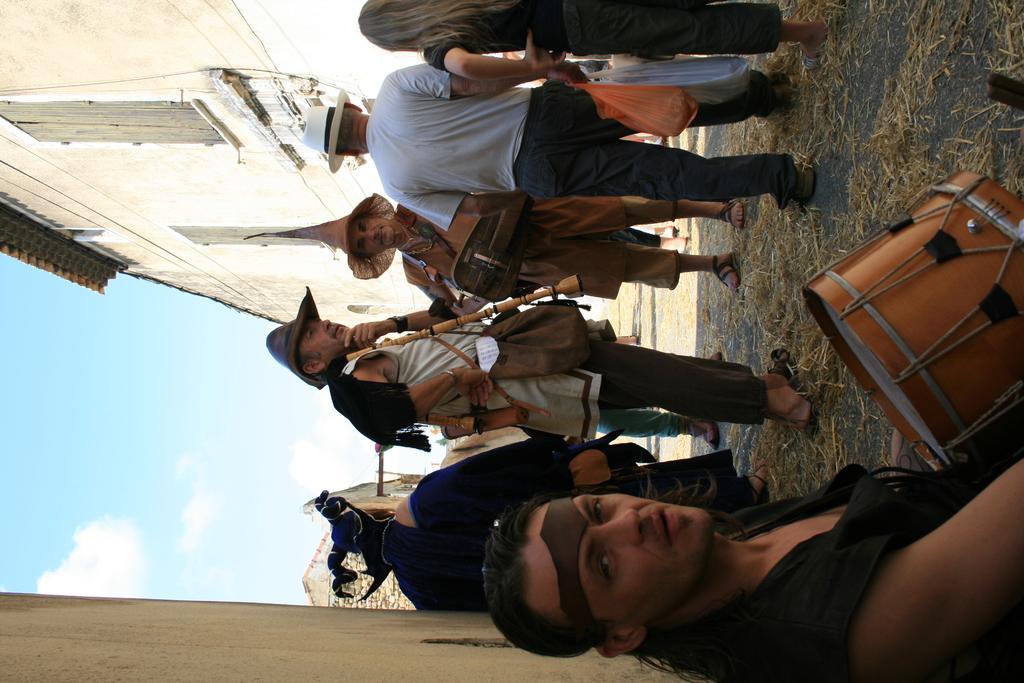How would you summarize this image in a sentence or two? A few people are standing in a street holding musical instruments. 